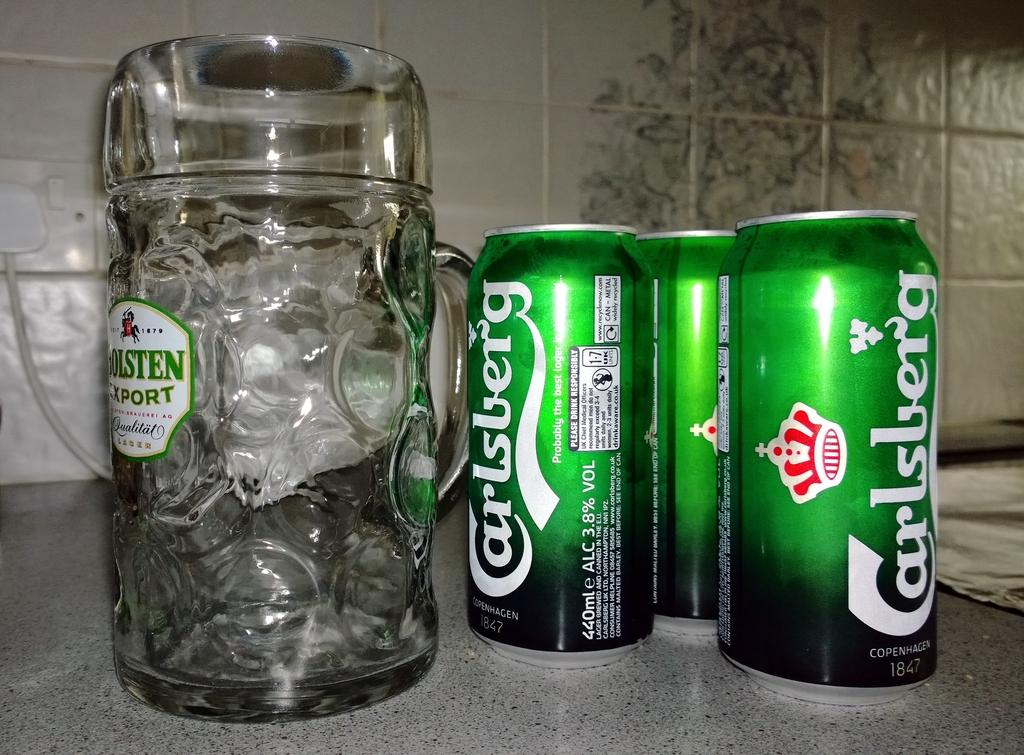<image>
Describe the image concisely. Three green cans of Carlsburg next to a glass stein. 